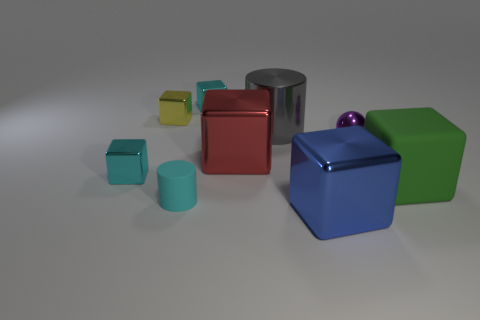How many cyan cubes are to the left of the green matte thing? 2 